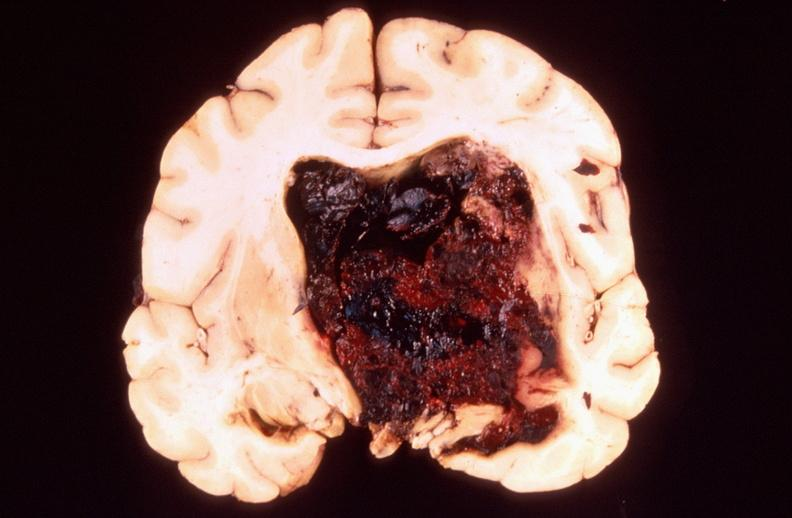what does this image show?
Answer the question using a single word or phrase. Brain 